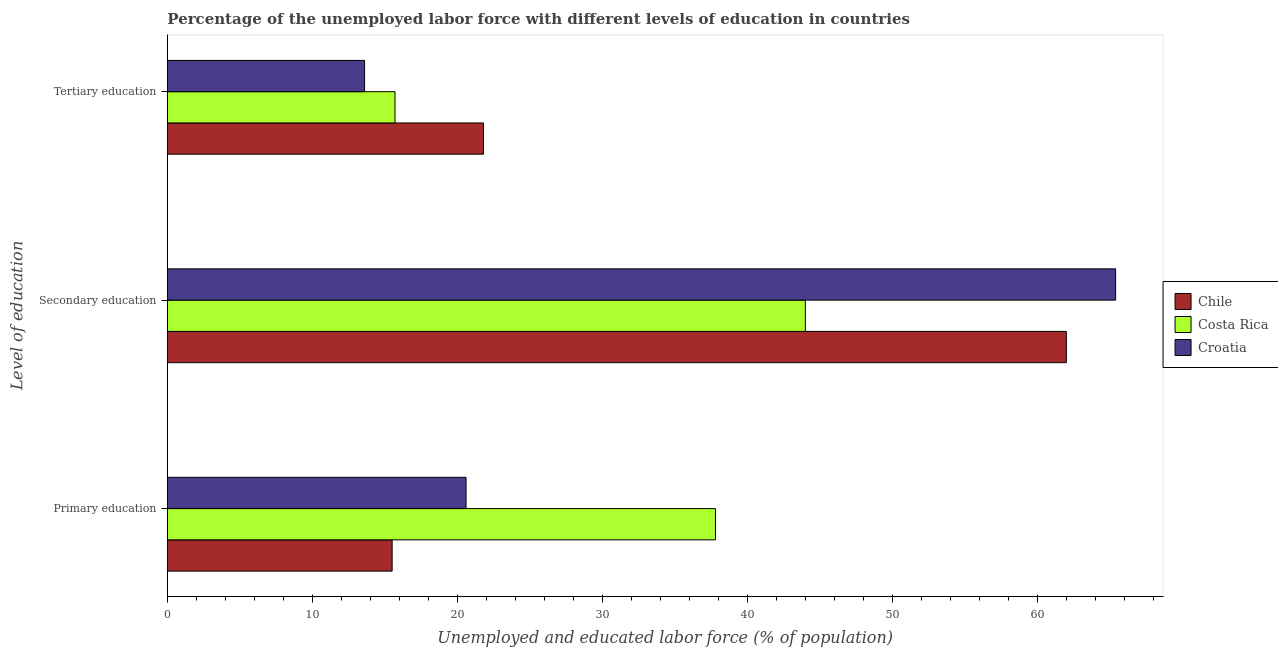How many different coloured bars are there?
Make the answer very short. 3. Are the number of bars per tick equal to the number of legend labels?
Your answer should be very brief. Yes. Are the number of bars on each tick of the Y-axis equal?
Provide a succinct answer. Yes. How many bars are there on the 3rd tick from the bottom?
Offer a terse response. 3. What is the label of the 3rd group of bars from the top?
Provide a short and direct response. Primary education. Across all countries, what is the maximum percentage of labor force who received tertiary education?
Provide a succinct answer. 21.8. In which country was the percentage of labor force who received secondary education maximum?
Make the answer very short. Croatia. In which country was the percentage of labor force who received tertiary education minimum?
Provide a succinct answer. Croatia. What is the total percentage of labor force who received primary education in the graph?
Make the answer very short. 73.9. What is the difference between the percentage of labor force who received tertiary education in Croatia and that in Chile?
Your response must be concise. -8.2. What is the difference between the percentage of labor force who received secondary education in Chile and the percentage of labor force who received primary education in Croatia?
Give a very brief answer. 41.4. What is the average percentage of labor force who received secondary education per country?
Your response must be concise. 57.13. What is the difference between the percentage of labor force who received secondary education and percentage of labor force who received primary education in Croatia?
Your answer should be compact. 44.8. What is the ratio of the percentage of labor force who received primary education in Costa Rica to that in Croatia?
Your answer should be very brief. 1.83. Is the percentage of labor force who received tertiary education in Croatia less than that in Chile?
Give a very brief answer. Yes. Is the difference between the percentage of labor force who received tertiary education in Chile and Croatia greater than the difference between the percentage of labor force who received secondary education in Chile and Croatia?
Your answer should be very brief. Yes. What is the difference between the highest and the second highest percentage of labor force who received secondary education?
Provide a short and direct response. 3.4. What is the difference between the highest and the lowest percentage of labor force who received secondary education?
Give a very brief answer. 21.4. In how many countries, is the percentage of labor force who received primary education greater than the average percentage of labor force who received primary education taken over all countries?
Provide a short and direct response. 1. What does the 2nd bar from the top in Tertiary education represents?
Your response must be concise. Costa Rica. What does the 2nd bar from the bottom in Primary education represents?
Keep it short and to the point. Costa Rica. How many bars are there?
Your answer should be compact. 9. How many countries are there in the graph?
Your answer should be compact. 3. Does the graph contain any zero values?
Your response must be concise. No. What is the title of the graph?
Your answer should be very brief. Percentage of the unemployed labor force with different levels of education in countries. What is the label or title of the X-axis?
Offer a very short reply. Unemployed and educated labor force (% of population). What is the label or title of the Y-axis?
Offer a terse response. Level of education. What is the Unemployed and educated labor force (% of population) in Chile in Primary education?
Your answer should be very brief. 15.5. What is the Unemployed and educated labor force (% of population) in Costa Rica in Primary education?
Provide a short and direct response. 37.8. What is the Unemployed and educated labor force (% of population) in Croatia in Primary education?
Provide a short and direct response. 20.6. What is the Unemployed and educated labor force (% of population) in Chile in Secondary education?
Give a very brief answer. 62. What is the Unemployed and educated labor force (% of population) of Croatia in Secondary education?
Provide a short and direct response. 65.4. What is the Unemployed and educated labor force (% of population) of Chile in Tertiary education?
Offer a terse response. 21.8. What is the Unemployed and educated labor force (% of population) in Costa Rica in Tertiary education?
Give a very brief answer. 15.7. What is the Unemployed and educated labor force (% of population) of Croatia in Tertiary education?
Your answer should be very brief. 13.6. Across all Level of education, what is the maximum Unemployed and educated labor force (% of population) in Croatia?
Give a very brief answer. 65.4. Across all Level of education, what is the minimum Unemployed and educated labor force (% of population) in Costa Rica?
Ensure brevity in your answer.  15.7. Across all Level of education, what is the minimum Unemployed and educated labor force (% of population) of Croatia?
Keep it short and to the point. 13.6. What is the total Unemployed and educated labor force (% of population) in Chile in the graph?
Provide a short and direct response. 99.3. What is the total Unemployed and educated labor force (% of population) in Costa Rica in the graph?
Offer a very short reply. 97.5. What is the total Unemployed and educated labor force (% of population) in Croatia in the graph?
Your response must be concise. 99.6. What is the difference between the Unemployed and educated labor force (% of population) of Chile in Primary education and that in Secondary education?
Offer a terse response. -46.5. What is the difference between the Unemployed and educated labor force (% of population) of Costa Rica in Primary education and that in Secondary education?
Your answer should be very brief. -6.2. What is the difference between the Unemployed and educated labor force (% of population) in Croatia in Primary education and that in Secondary education?
Your answer should be compact. -44.8. What is the difference between the Unemployed and educated labor force (% of population) in Costa Rica in Primary education and that in Tertiary education?
Ensure brevity in your answer.  22.1. What is the difference between the Unemployed and educated labor force (% of population) in Chile in Secondary education and that in Tertiary education?
Your response must be concise. 40.2. What is the difference between the Unemployed and educated labor force (% of population) in Costa Rica in Secondary education and that in Tertiary education?
Offer a very short reply. 28.3. What is the difference between the Unemployed and educated labor force (% of population) in Croatia in Secondary education and that in Tertiary education?
Make the answer very short. 51.8. What is the difference between the Unemployed and educated labor force (% of population) in Chile in Primary education and the Unemployed and educated labor force (% of population) in Costa Rica in Secondary education?
Ensure brevity in your answer.  -28.5. What is the difference between the Unemployed and educated labor force (% of population) of Chile in Primary education and the Unemployed and educated labor force (% of population) of Croatia in Secondary education?
Keep it short and to the point. -49.9. What is the difference between the Unemployed and educated labor force (% of population) of Costa Rica in Primary education and the Unemployed and educated labor force (% of population) of Croatia in Secondary education?
Keep it short and to the point. -27.6. What is the difference between the Unemployed and educated labor force (% of population) in Chile in Primary education and the Unemployed and educated labor force (% of population) in Costa Rica in Tertiary education?
Your answer should be compact. -0.2. What is the difference between the Unemployed and educated labor force (% of population) in Chile in Primary education and the Unemployed and educated labor force (% of population) in Croatia in Tertiary education?
Provide a short and direct response. 1.9. What is the difference between the Unemployed and educated labor force (% of population) in Costa Rica in Primary education and the Unemployed and educated labor force (% of population) in Croatia in Tertiary education?
Provide a succinct answer. 24.2. What is the difference between the Unemployed and educated labor force (% of population) in Chile in Secondary education and the Unemployed and educated labor force (% of population) in Costa Rica in Tertiary education?
Make the answer very short. 46.3. What is the difference between the Unemployed and educated labor force (% of population) in Chile in Secondary education and the Unemployed and educated labor force (% of population) in Croatia in Tertiary education?
Give a very brief answer. 48.4. What is the difference between the Unemployed and educated labor force (% of population) of Costa Rica in Secondary education and the Unemployed and educated labor force (% of population) of Croatia in Tertiary education?
Offer a terse response. 30.4. What is the average Unemployed and educated labor force (% of population) in Chile per Level of education?
Offer a terse response. 33.1. What is the average Unemployed and educated labor force (% of population) in Costa Rica per Level of education?
Your answer should be very brief. 32.5. What is the average Unemployed and educated labor force (% of population) of Croatia per Level of education?
Make the answer very short. 33.2. What is the difference between the Unemployed and educated labor force (% of population) of Chile and Unemployed and educated labor force (% of population) of Costa Rica in Primary education?
Provide a short and direct response. -22.3. What is the difference between the Unemployed and educated labor force (% of population) in Costa Rica and Unemployed and educated labor force (% of population) in Croatia in Primary education?
Offer a terse response. 17.2. What is the difference between the Unemployed and educated labor force (% of population) in Costa Rica and Unemployed and educated labor force (% of population) in Croatia in Secondary education?
Offer a very short reply. -21.4. What is the difference between the Unemployed and educated labor force (% of population) in Chile and Unemployed and educated labor force (% of population) in Costa Rica in Tertiary education?
Provide a short and direct response. 6.1. What is the difference between the Unemployed and educated labor force (% of population) of Chile and Unemployed and educated labor force (% of population) of Croatia in Tertiary education?
Your response must be concise. 8.2. What is the ratio of the Unemployed and educated labor force (% of population) of Chile in Primary education to that in Secondary education?
Your answer should be very brief. 0.25. What is the ratio of the Unemployed and educated labor force (% of population) of Costa Rica in Primary education to that in Secondary education?
Give a very brief answer. 0.86. What is the ratio of the Unemployed and educated labor force (% of population) in Croatia in Primary education to that in Secondary education?
Provide a short and direct response. 0.32. What is the ratio of the Unemployed and educated labor force (% of population) of Chile in Primary education to that in Tertiary education?
Ensure brevity in your answer.  0.71. What is the ratio of the Unemployed and educated labor force (% of population) of Costa Rica in Primary education to that in Tertiary education?
Your answer should be compact. 2.41. What is the ratio of the Unemployed and educated labor force (% of population) in Croatia in Primary education to that in Tertiary education?
Provide a short and direct response. 1.51. What is the ratio of the Unemployed and educated labor force (% of population) in Chile in Secondary education to that in Tertiary education?
Your answer should be very brief. 2.84. What is the ratio of the Unemployed and educated labor force (% of population) of Costa Rica in Secondary education to that in Tertiary education?
Provide a short and direct response. 2.8. What is the ratio of the Unemployed and educated labor force (% of population) in Croatia in Secondary education to that in Tertiary education?
Your answer should be very brief. 4.81. What is the difference between the highest and the second highest Unemployed and educated labor force (% of population) in Chile?
Ensure brevity in your answer.  40.2. What is the difference between the highest and the second highest Unemployed and educated labor force (% of population) in Croatia?
Your answer should be compact. 44.8. What is the difference between the highest and the lowest Unemployed and educated labor force (% of population) of Chile?
Offer a very short reply. 46.5. What is the difference between the highest and the lowest Unemployed and educated labor force (% of population) in Costa Rica?
Provide a short and direct response. 28.3. What is the difference between the highest and the lowest Unemployed and educated labor force (% of population) in Croatia?
Keep it short and to the point. 51.8. 